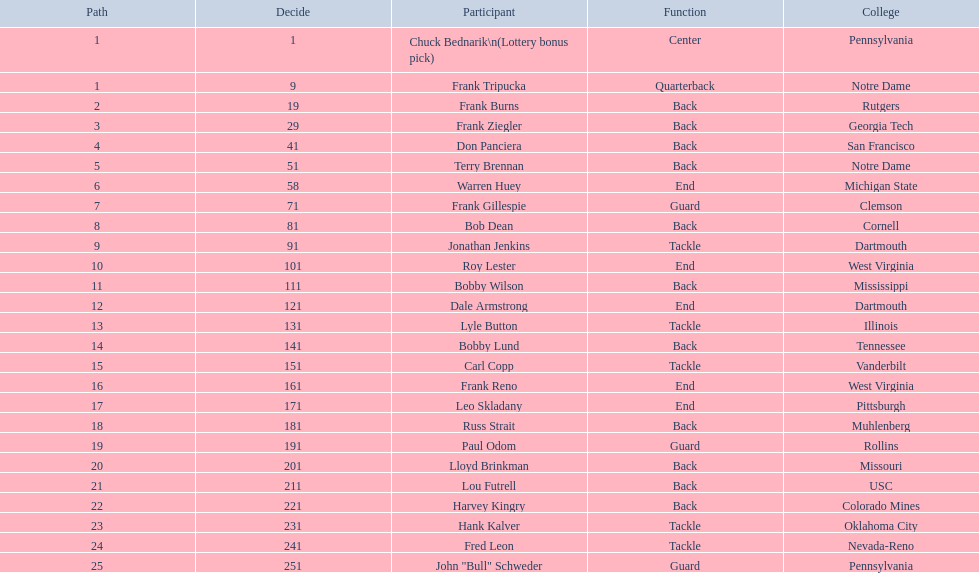Greatest rd figure? 25. 